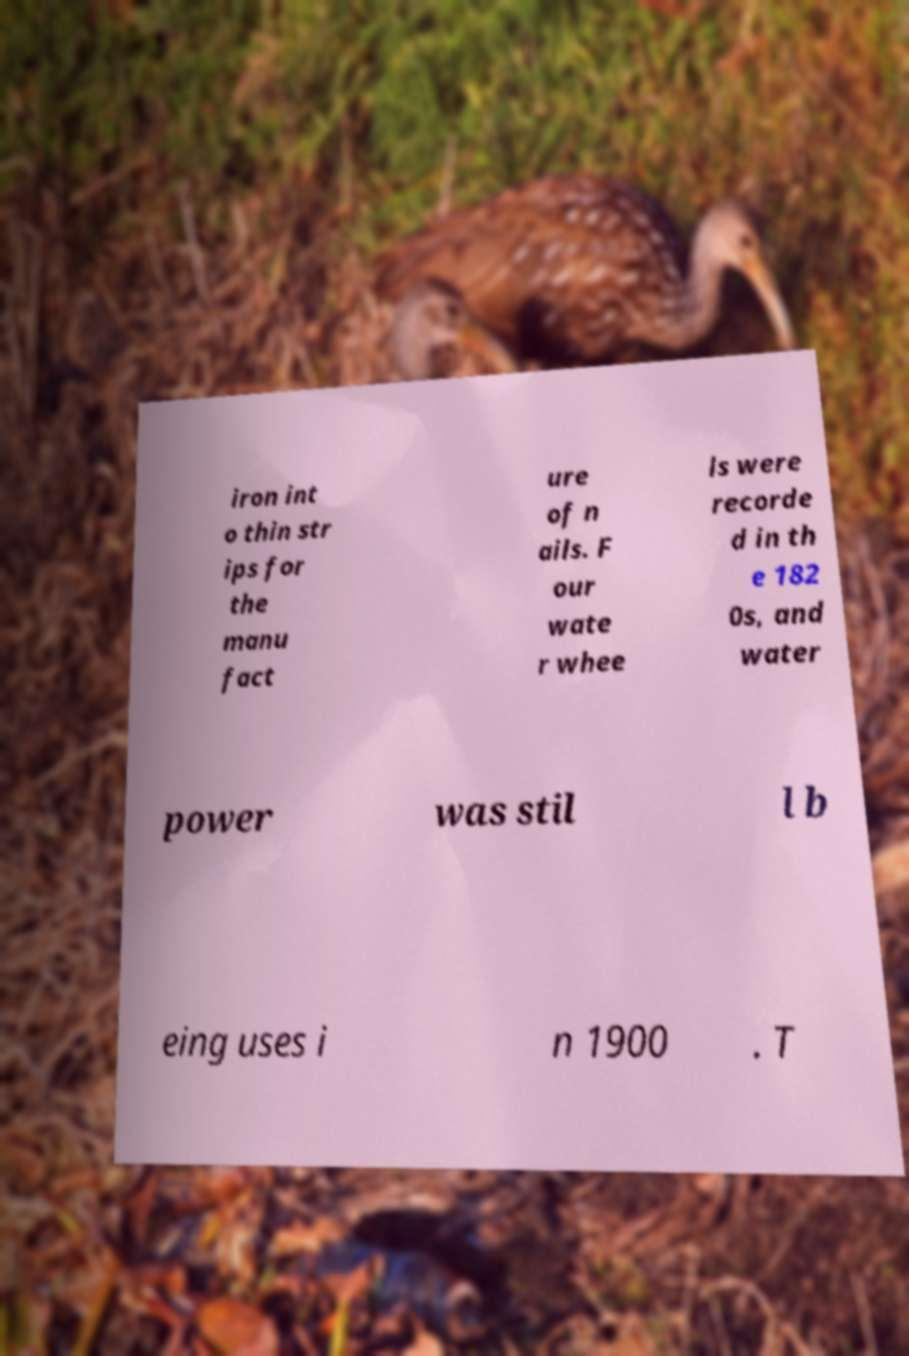Please identify and transcribe the text found in this image. iron int o thin str ips for the manu fact ure of n ails. F our wate r whee ls were recorde d in th e 182 0s, and water power was stil l b eing uses i n 1900 . T 